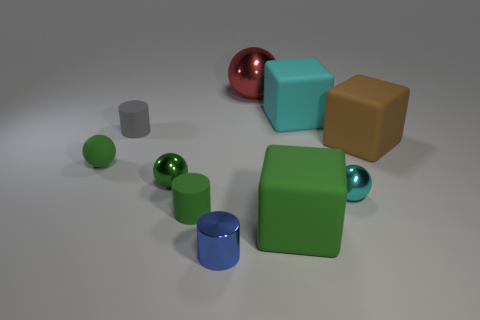What is the color of the tiny object that is in front of the large matte block on the left side of the big cyan matte cube that is behind the green cylinder?
Your answer should be compact. Blue. Is the red sphere the same size as the green matte sphere?
Keep it short and to the point. No. Are there any other things that have the same shape as the cyan metal thing?
Your response must be concise. Yes. How many objects are metallic things that are left of the red metal object or cyan rubber things?
Give a very brief answer. 3. Does the green metallic thing have the same shape as the large cyan object?
Give a very brief answer. No. What number of other things are there of the same size as the gray rubber cylinder?
Offer a very short reply. 5. The small rubber sphere is what color?
Keep it short and to the point. Green. How many tiny objects are either rubber cubes or metal cylinders?
Offer a terse response. 1. There is a green thing to the right of the tiny blue metal thing; is its size the same as the rubber cylinder that is behind the small rubber sphere?
Your answer should be very brief. No. There is a rubber thing that is the same shape as the cyan metallic object; what is its size?
Provide a short and direct response. Small. 